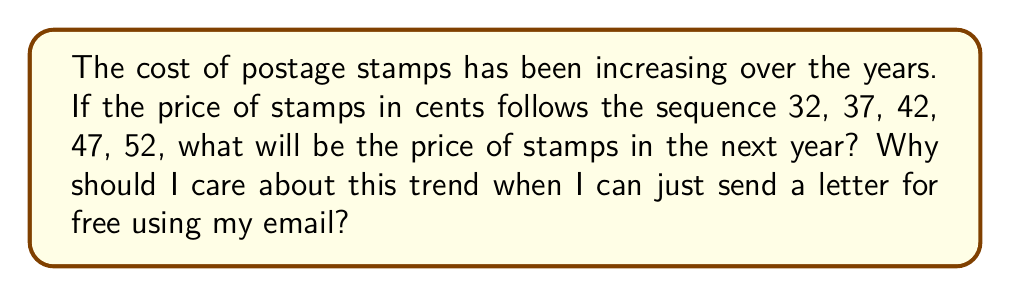Help me with this question. Let's analyze this sequence step-by-step:

1) First, let's look at the differences between consecutive terms:
   $37 - 32 = 5$
   $42 - 37 = 5$
   $47 - 42 = 5$
   $52 - 47 = 5$

2) We can see that the difference is consistently 5 cents.

3) This is an arithmetic sequence, where each term increases by a constant amount (5 cents) from the previous term.

4) To find the next term, we add 5 to the last given term:
   $52 + 5 = 57$

5) Therefore, the next stamp price in the sequence would be 57 cents.

As for why you should care about this trend even though you can send emails for free:
While it's true that emails are free and convenient, there are still many situations where physical mail is necessary or preferred, such as sending official documents, birthday cards, or packages. Understanding this trend can help you budget for future mailing costs and appreciate the value of alternative communication methods like email.
Answer: 57 cents 